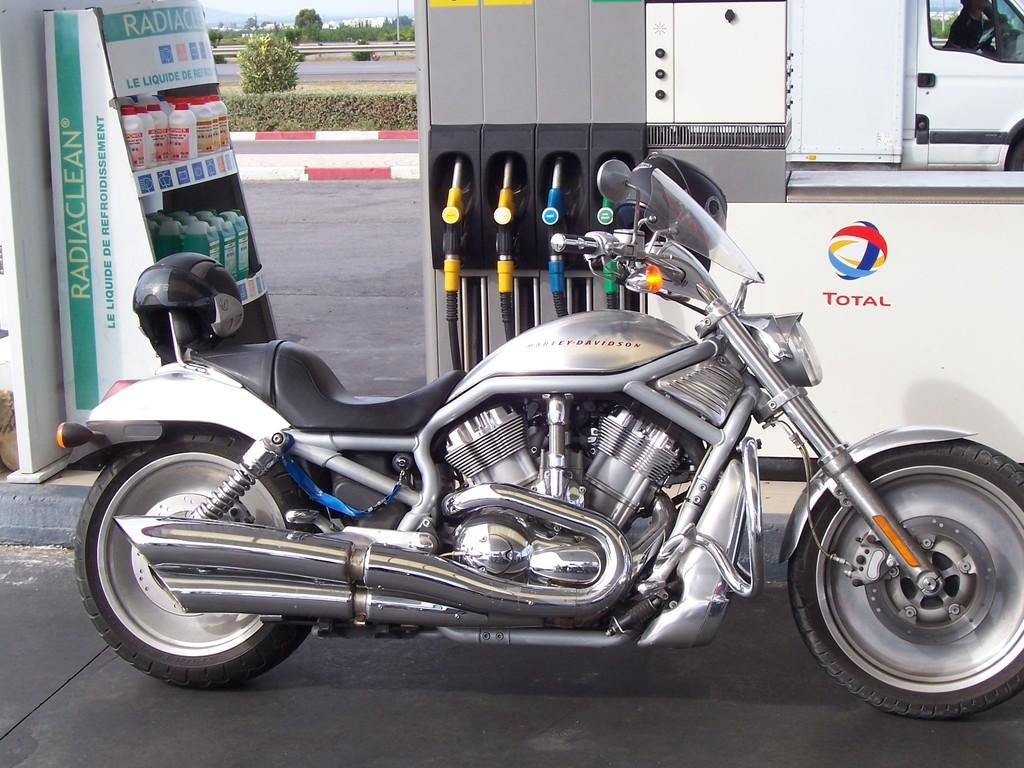What is the main object in the image? There is a bike in the image. Can you describe the color of the bike? The bike is silver and black in color. What can be seen in the background of the image? There are trees in the background of the image. What is the color of the trees? The trees are green in color. What else is visible in the background? There are bottles visible in the background. How would you describe the sky in the image? The sky is white in color. Can you tell me how many people are swimming in the ocean in the image? There is no ocean or people swimming present in the image; it features a bike with a background of trees, bottles, and a white sky. 